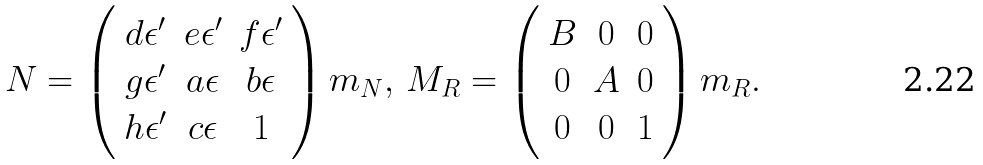<formula> <loc_0><loc_0><loc_500><loc_500>N = \left ( \begin{array} { c c c } d \epsilon ^ { \prime } & e \epsilon ^ { \prime } & f \epsilon ^ { \prime } \\ g \epsilon ^ { \prime } & a \epsilon & b \epsilon \\ h \epsilon ^ { \prime } & c \epsilon & 1 \end{array} \right ) m _ { N } , \, M _ { R } = \left ( \begin{array} { c c c } B & 0 & 0 \\ 0 & A & 0 \\ 0 & 0 & 1 \end{array} \right ) m _ { R } .</formula> 